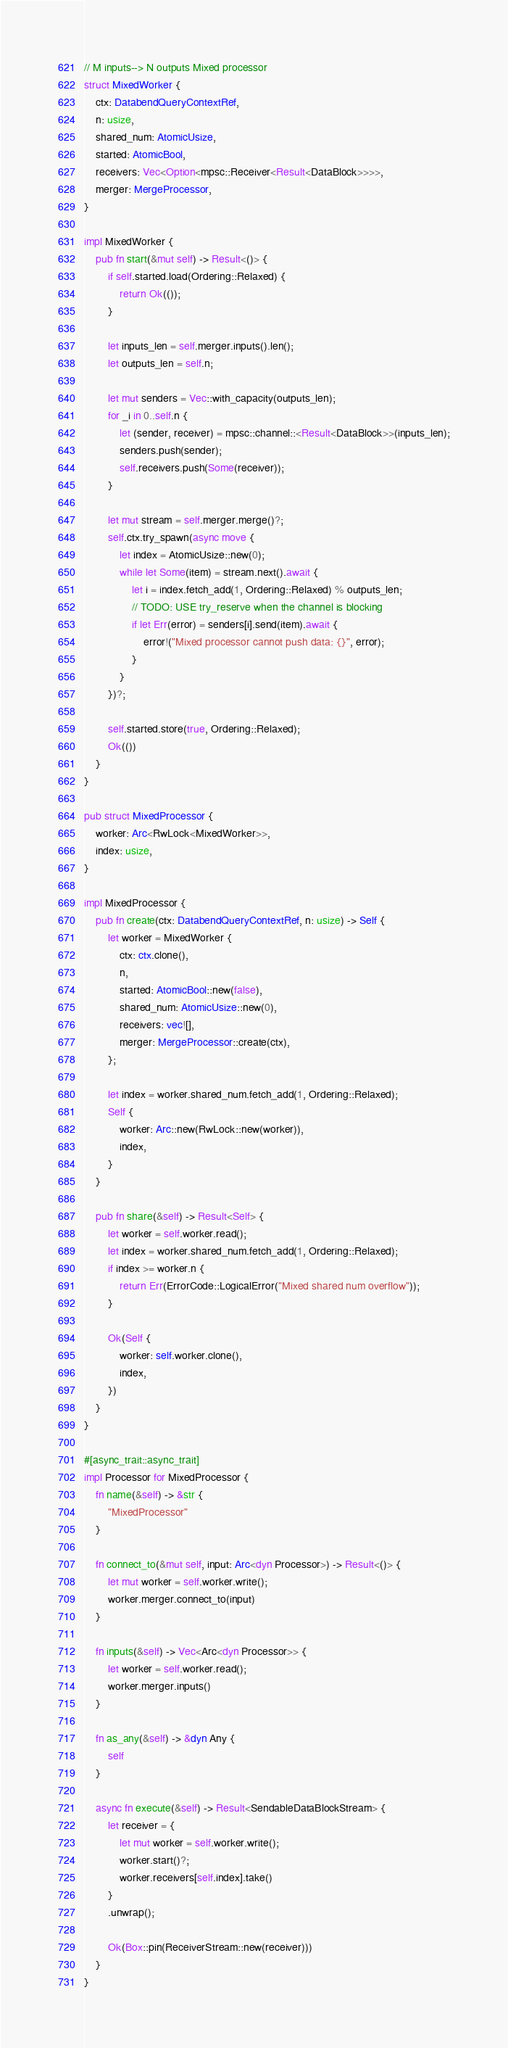<code> <loc_0><loc_0><loc_500><loc_500><_Rust_>
// M inputs--> N outputs Mixed processor
struct MixedWorker {
    ctx: DatabendQueryContextRef,
    n: usize,
    shared_num: AtomicUsize,
    started: AtomicBool,
    receivers: Vec<Option<mpsc::Receiver<Result<DataBlock>>>>,
    merger: MergeProcessor,
}

impl MixedWorker {
    pub fn start(&mut self) -> Result<()> {
        if self.started.load(Ordering::Relaxed) {
            return Ok(());
        }

        let inputs_len = self.merger.inputs().len();
        let outputs_len = self.n;

        let mut senders = Vec::with_capacity(outputs_len);
        for _i in 0..self.n {
            let (sender, receiver) = mpsc::channel::<Result<DataBlock>>(inputs_len);
            senders.push(sender);
            self.receivers.push(Some(receiver));
        }

        let mut stream = self.merger.merge()?;
        self.ctx.try_spawn(async move {
            let index = AtomicUsize::new(0);
            while let Some(item) = stream.next().await {
                let i = index.fetch_add(1, Ordering::Relaxed) % outputs_len;
                // TODO: USE try_reserve when the channel is blocking
                if let Err(error) = senders[i].send(item).await {
                    error!("Mixed processor cannot push data: {}", error);
                }
            }
        })?;

        self.started.store(true, Ordering::Relaxed);
        Ok(())
    }
}

pub struct MixedProcessor {
    worker: Arc<RwLock<MixedWorker>>,
    index: usize,
}

impl MixedProcessor {
    pub fn create(ctx: DatabendQueryContextRef, n: usize) -> Self {
        let worker = MixedWorker {
            ctx: ctx.clone(),
            n,
            started: AtomicBool::new(false),
            shared_num: AtomicUsize::new(0),
            receivers: vec![],
            merger: MergeProcessor::create(ctx),
        };

        let index = worker.shared_num.fetch_add(1, Ordering::Relaxed);
        Self {
            worker: Arc::new(RwLock::new(worker)),
            index,
        }
    }

    pub fn share(&self) -> Result<Self> {
        let worker = self.worker.read();
        let index = worker.shared_num.fetch_add(1, Ordering::Relaxed);
        if index >= worker.n {
            return Err(ErrorCode::LogicalError("Mixed shared num overflow"));
        }

        Ok(Self {
            worker: self.worker.clone(),
            index,
        })
    }
}

#[async_trait::async_trait]
impl Processor for MixedProcessor {
    fn name(&self) -> &str {
        "MixedProcessor"
    }

    fn connect_to(&mut self, input: Arc<dyn Processor>) -> Result<()> {
        let mut worker = self.worker.write();
        worker.merger.connect_to(input)
    }

    fn inputs(&self) -> Vec<Arc<dyn Processor>> {
        let worker = self.worker.read();
        worker.merger.inputs()
    }

    fn as_any(&self) -> &dyn Any {
        self
    }

    async fn execute(&self) -> Result<SendableDataBlockStream> {
        let receiver = {
            let mut worker = self.worker.write();
            worker.start()?;
            worker.receivers[self.index].take()
        }
        .unwrap();

        Ok(Box::pin(ReceiverStream::new(receiver)))
    }
}
</code> 